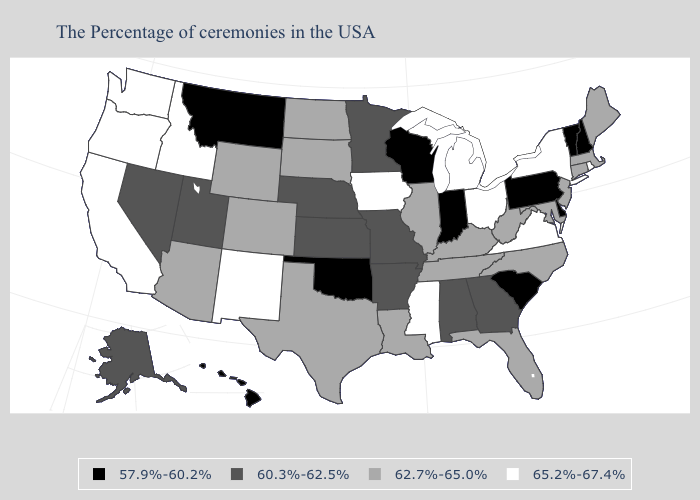Does Arizona have a lower value than Michigan?
Give a very brief answer. Yes. Name the states that have a value in the range 65.2%-67.4%?
Answer briefly. Rhode Island, New York, Virginia, Ohio, Michigan, Mississippi, Iowa, New Mexico, Idaho, California, Washington, Oregon. Name the states that have a value in the range 60.3%-62.5%?
Give a very brief answer. Georgia, Alabama, Missouri, Arkansas, Minnesota, Kansas, Nebraska, Utah, Nevada, Alaska. Which states have the highest value in the USA?
Be succinct. Rhode Island, New York, Virginia, Ohio, Michigan, Mississippi, Iowa, New Mexico, Idaho, California, Washington, Oregon. What is the lowest value in the Northeast?
Quick response, please. 57.9%-60.2%. Name the states that have a value in the range 62.7%-65.0%?
Short answer required. Maine, Massachusetts, Connecticut, New Jersey, Maryland, North Carolina, West Virginia, Florida, Kentucky, Tennessee, Illinois, Louisiana, Texas, South Dakota, North Dakota, Wyoming, Colorado, Arizona. Which states have the highest value in the USA?
Concise answer only. Rhode Island, New York, Virginia, Ohio, Michigan, Mississippi, Iowa, New Mexico, Idaho, California, Washington, Oregon. What is the value of Tennessee?
Give a very brief answer. 62.7%-65.0%. Among the states that border Pennsylvania , which have the highest value?
Give a very brief answer. New York, Ohio. How many symbols are there in the legend?
Write a very short answer. 4. What is the value of California?
Keep it brief. 65.2%-67.4%. Name the states that have a value in the range 57.9%-60.2%?
Answer briefly. New Hampshire, Vermont, Delaware, Pennsylvania, South Carolina, Indiana, Wisconsin, Oklahoma, Montana, Hawaii. Does Montana have the highest value in the USA?
Quick response, please. No. What is the value of Washington?
Quick response, please. 65.2%-67.4%. What is the value of New Mexico?
Concise answer only. 65.2%-67.4%. 